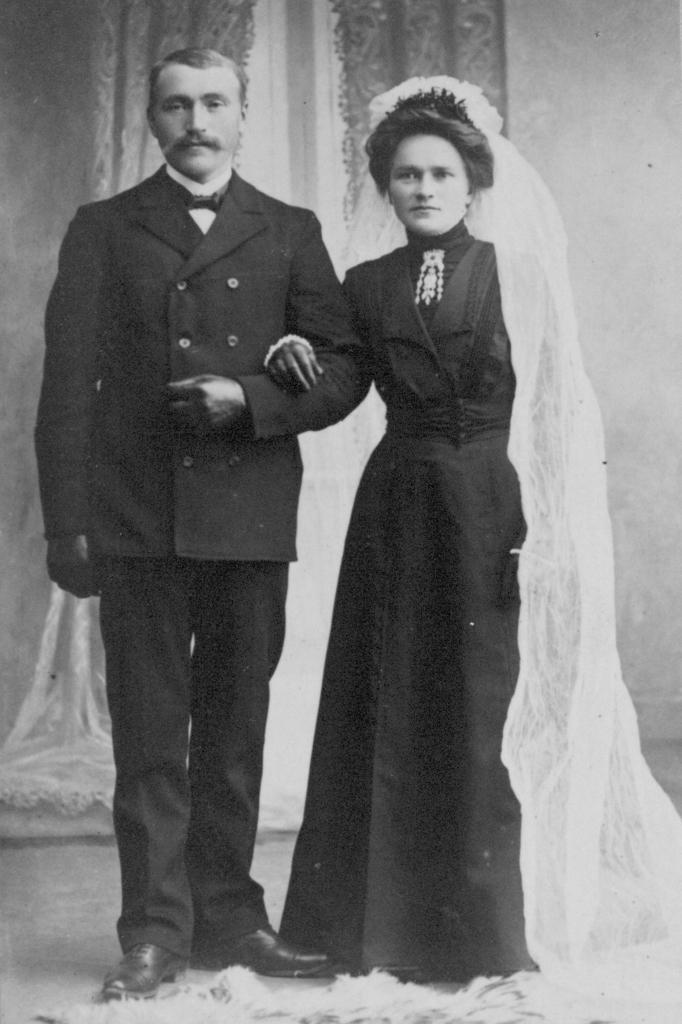How many people are present in the image? There are two people, a man and a woman, present in the image. What are the man and woman doing in the image? Both the man and woman are standing on the floor in the image. What can be seen behind the man and woman? There is a wall visible in the image. Are there any window treatments present in the image? Yes, there are curtains in the image. What type of stone can be seen on the boat in the image? There is no boat or stone present in the image; it features a man and a woman standing near a wall with curtains. 